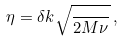Convert formula to latex. <formula><loc_0><loc_0><loc_500><loc_500>\eta = \delta k \sqrt { \frac { } { 2 M \nu } } \, ,</formula> 